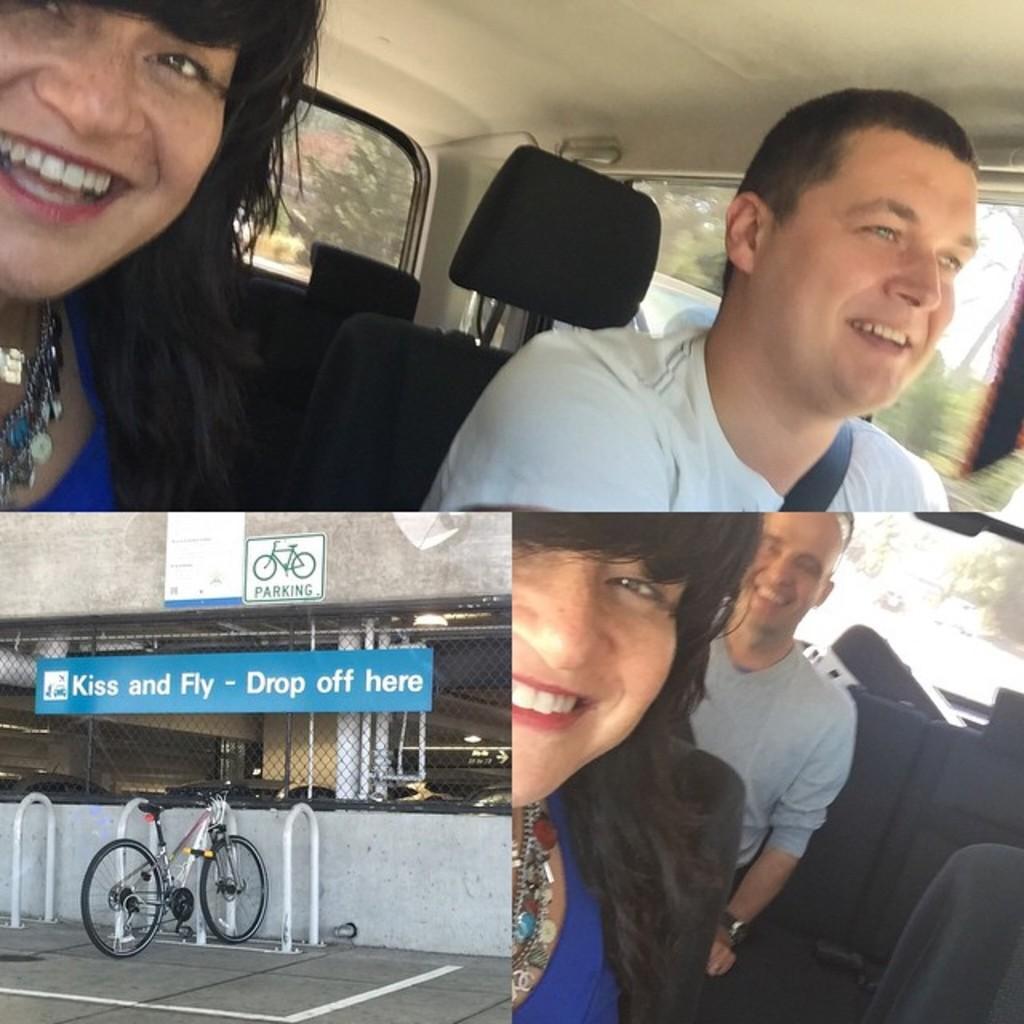Describe this image in one or two sentences. This image contains a collage of photos. Top of the image two people are sitting in the vehicle. Left bottom there is a bicycle on the pavement. There is a board attached to the fence. Few boards are attached to the wall. Right bottom two people are sitting in the vehicle. From the window of the vehicle few trees are visible. 